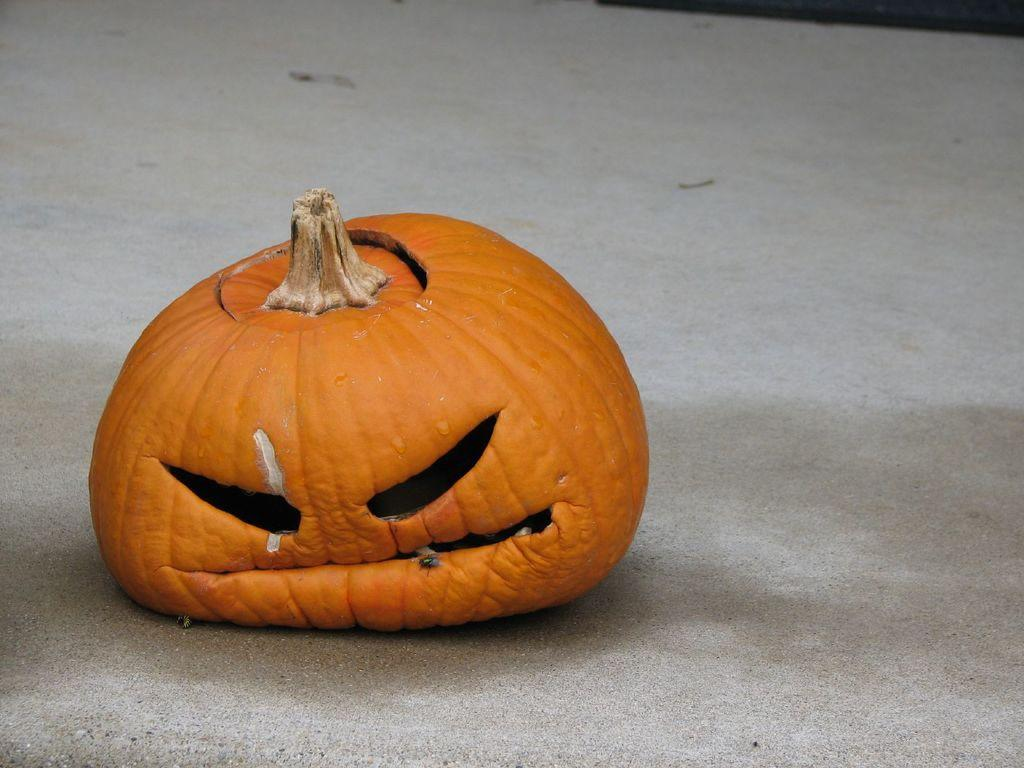What is the main object in the image? There is a pumpkin in the image. What type of secretary can be seen working in the image? There is no secretary present in the image; it only features a pumpkin. What type of bat is flying near the pumpkin in the image? There is no bat present in the image; it only features a pumpkin. 